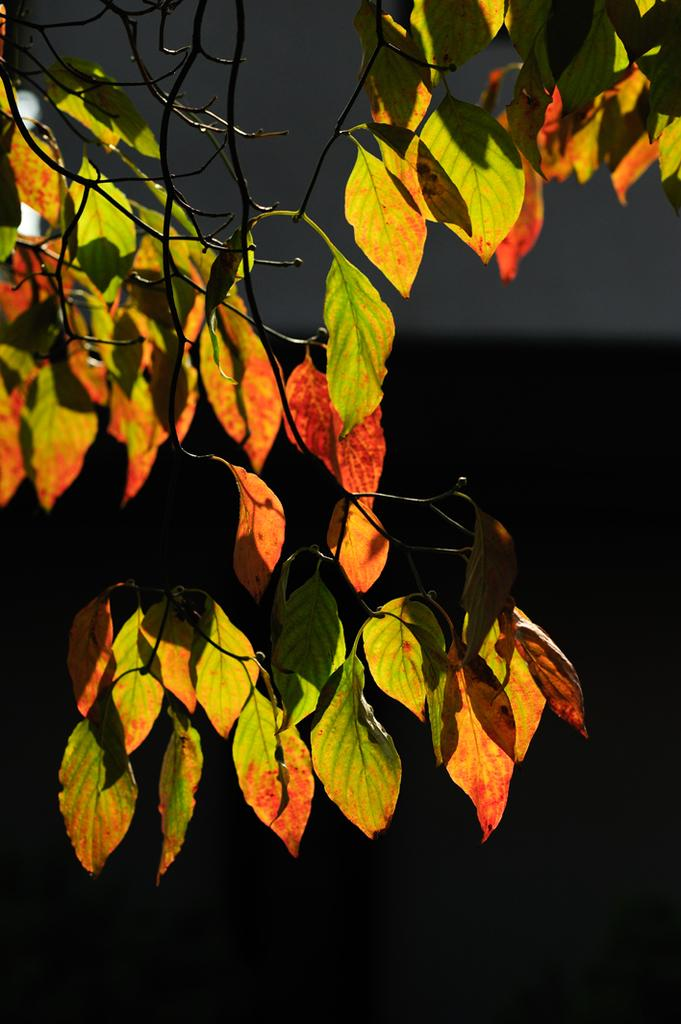What type of plant material can be seen in the image? There are leaves in the image. Are the leaves connected to anything? Yes, the leaves are attached to a stem. Can you tell me how long the cord is in the image? There is no cord present in the image; it only features leaves and a stem. 